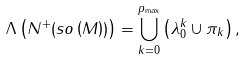<formula> <loc_0><loc_0><loc_500><loc_500>\Lambda \left ( N ^ { + } ( s o \left ( M \right ) ) \right ) = \bigcup _ { k = 0 } ^ { p _ { \max } } \left ( \lambda _ { 0 } ^ { k } \cup \pi _ { k } \right ) ,</formula> 